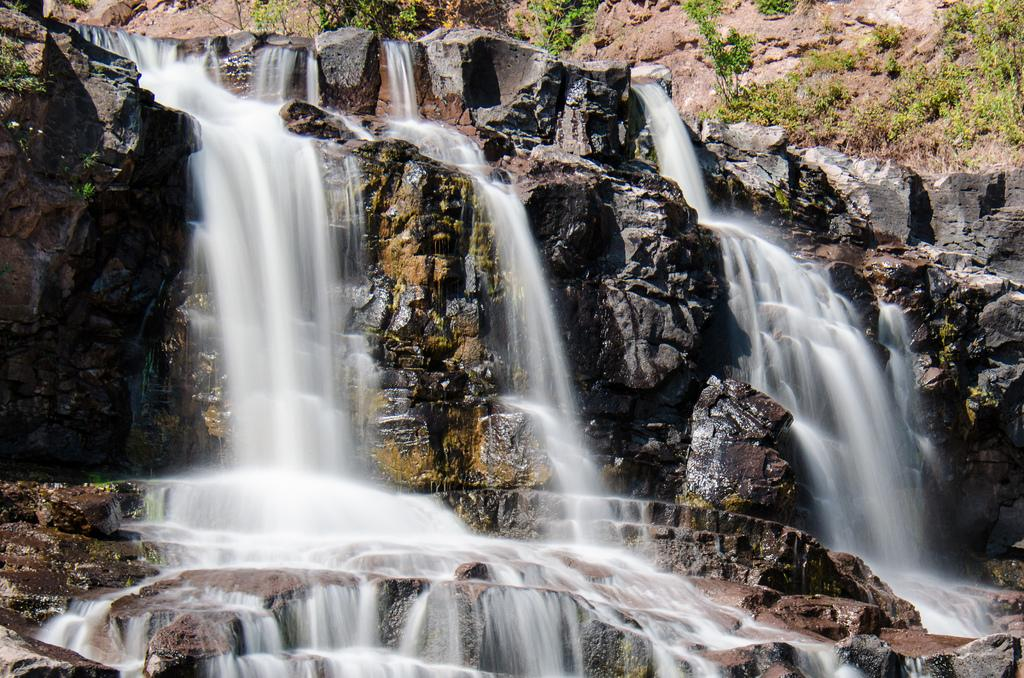What natural feature is the main subject of the image? There is a waterfall in the image. What type of vegetation can be seen in the top right of the image? There are plants and grass in the top right of the image. What type of geological formation is on the left side of the image? There is a stone mountain on the left side of the image. Can you hear the pest crying in the image? There is no pest or crying sound present in the image; it features a waterfall, plants, grass, and a stone mountain. 